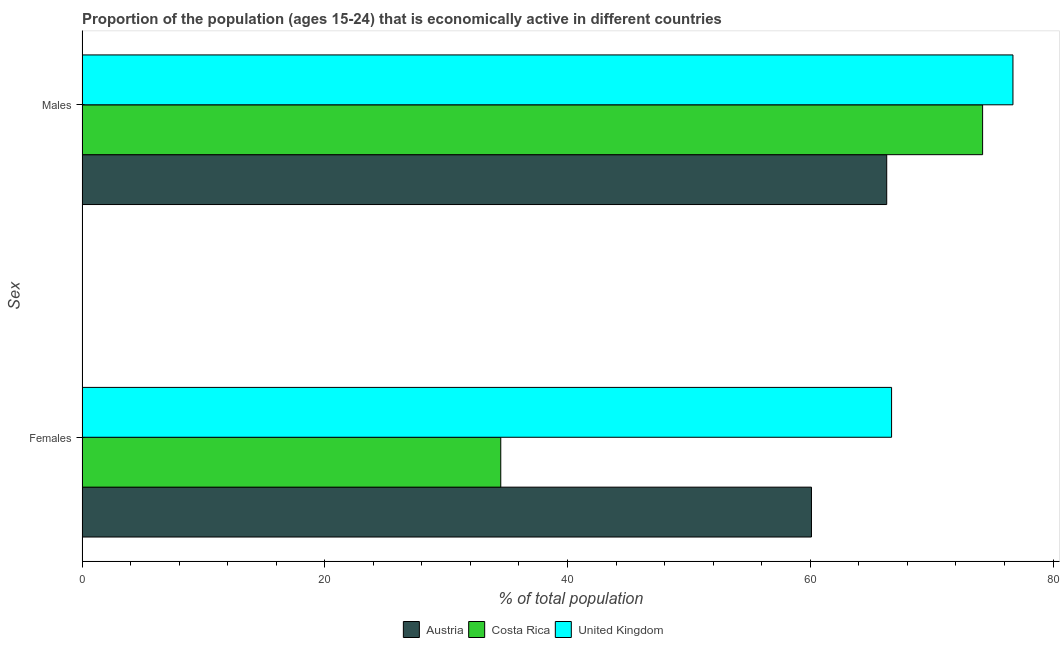How many different coloured bars are there?
Make the answer very short. 3. Are the number of bars on each tick of the Y-axis equal?
Provide a succinct answer. Yes. How many bars are there on the 1st tick from the top?
Your answer should be compact. 3. How many bars are there on the 1st tick from the bottom?
Provide a short and direct response. 3. What is the label of the 1st group of bars from the top?
Offer a very short reply. Males. What is the percentage of economically active female population in Austria?
Your answer should be compact. 60.1. Across all countries, what is the maximum percentage of economically active female population?
Provide a succinct answer. 66.7. Across all countries, what is the minimum percentage of economically active female population?
Keep it short and to the point. 34.5. What is the total percentage of economically active female population in the graph?
Provide a succinct answer. 161.3. What is the difference between the percentage of economically active female population in Costa Rica and that in Austria?
Offer a very short reply. -25.6. What is the difference between the percentage of economically active male population in Costa Rica and the percentage of economically active female population in Austria?
Offer a terse response. 14.1. What is the average percentage of economically active female population per country?
Give a very brief answer. 53.77. What is the difference between the percentage of economically active female population and percentage of economically active male population in Costa Rica?
Give a very brief answer. -39.7. What is the ratio of the percentage of economically active female population in Austria to that in United Kingdom?
Provide a succinct answer. 0.9. Is the percentage of economically active male population in Costa Rica less than that in United Kingdom?
Your response must be concise. Yes. In how many countries, is the percentage of economically active female population greater than the average percentage of economically active female population taken over all countries?
Provide a short and direct response. 2. What does the 2nd bar from the bottom in Males represents?
Give a very brief answer. Costa Rica. How many countries are there in the graph?
Ensure brevity in your answer.  3. Does the graph contain any zero values?
Provide a succinct answer. No. Does the graph contain grids?
Your answer should be compact. No. Where does the legend appear in the graph?
Your answer should be very brief. Bottom center. What is the title of the graph?
Offer a very short reply. Proportion of the population (ages 15-24) that is economically active in different countries. What is the label or title of the X-axis?
Your response must be concise. % of total population. What is the label or title of the Y-axis?
Provide a short and direct response. Sex. What is the % of total population in Austria in Females?
Offer a terse response. 60.1. What is the % of total population of Costa Rica in Females?
Your response must be concise. 34.5. What is the % of total population of United Kingdom in Females?
Your answer should be very brief. 66.7. What is the % of total population of Austria in Males?
Provide a short and direct response. 66.3. What is the % of total population of Costa Rica in Males?
Keep it short and to the point. 74.2. What is the % of total population of United Kingdom in Males?
Give a very brief answer. 76.7. Across all Sex, what is the maximum % of total population in Austria?
Offer a terse response. 66.3. Across all Sex, what is the maximum % of total population of Costa Rica?
Provide a short and direct response. 74.2. Across all Sex, what is the maximum % of total population of United Kingdom?
Provide a succinct answer. 76.7. Across all Sex, what is the minimum % of total population in Austria?
Give a very brief answer. 60.1. Across all Sex, what is the minimum % of total population in Costa Rica?
Offer a very short reply. 34.5. Across all Sex, what is the minimum % of total population in United Kingdom?
Provide a succinct answer. 66.7. What is the total % of total population in Austria in the graph?
Give a very brief answer. 126.4. What is the total % of total population in Costa Rica in the graph?
Provide a short and direct response. 108.7. What is the total % of total population of United Kingdom in the graph?
Offer a terse response. 143.4. What is the difference between the % of total population in Costa Rica in Females and that in Males?
Your response must be concise. -39.7. What is the difference between the % of total population in United Kingdom in Females and that in Males?
Make the answer very short. -10. What is the difference between the % of total population of Austria in Females and the % of total population of Costa Rica in Males?
Offer a terse response. -14.1. What is the difference between the % of total population in Austria in Females and the % of total population in United Kingdom in Males?
Ensure brevity in your answer.  -16.6. What is the difference between the % of total population of Costa Rica in Females and the % of total population of United Kingdom in Males?
Your answer should be compact. -42.2. What is the average % of total population of Austria per Sex?
Provide a short and direct response. 63.2. What is the average % of total population of Costa Rica per Sex?
Give a very brief answer. 54.35. What is the average % of total population of United Kingdom per Sex?
Provide a short and direct response. 71.7. What is the difference between the % of total population in Austria and % of total population in Costa Rica in Females?
Your response must be concise. 25.6. What is the difference between the % of total population of Austria and % of total population of United Kingdom in Females?
Make the answer very short. -6.6. What is the difference between the % of total population of Costa Rica and % of total population of United Kingdom in Females?
Make the answer very short. -32.2. What is the difference between the % of total population of Costa Rica and % of total population of United Kingdom in Males?
Your answer should be very brief. -2.5. What is the ratio of the % of total population of Austria in Females to that in Males?
Ensure brevity in your answer.  0.91. What is the ratio of the % of total population in Costa Rica in Females to that in Males?
Make the answer very short. 0.47. What is the ratio of the % of total population in United Kingdom in Females to that in Males?
Your response must be concise. 0.87. What is the difference between the highest and the second highest % of total population in Austria?
Your answer should be very brief. 6.2. What is the difference between the highest and the second highest % of total population in Costa Rica?
Provide a succinct answer. 39.7. What is the difference between the highest and the second highest % of total population in United Kingdom?
Offer a terse response. 10. What is the difference between the highest and the lowest % of total population in Costa Rica?
Offer a very short reply. 39.7. What is the difference between the highest and the lowest % of total population in United Kingdom?
Provide a succinct answer. 10. 